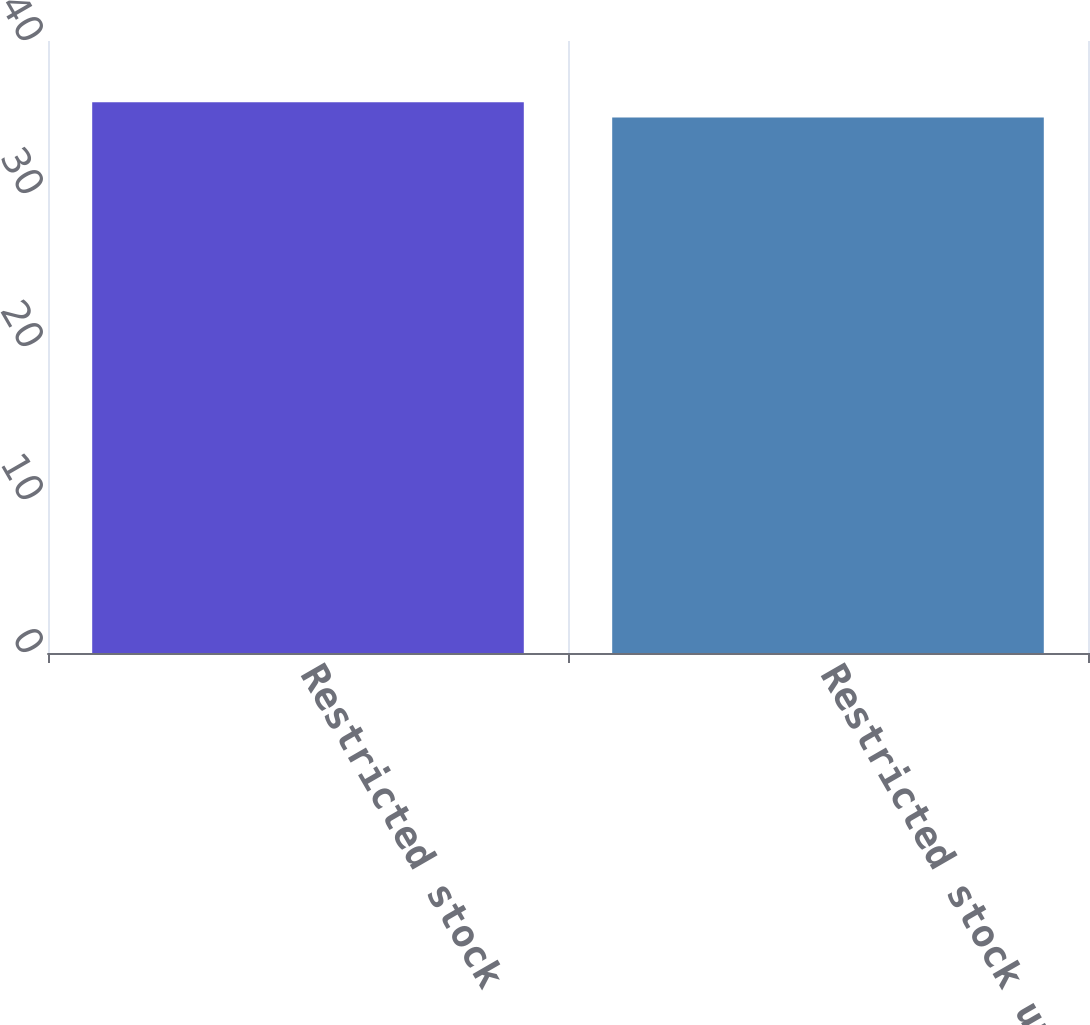Convert chart to OTSL. <chart><loc_0><loc_0><loc_500><loc_500><bar_chart><fcel>Restricted stock<fcel>Restricted stock units<nl><fcel>36<fcel>35<nl></chart> 